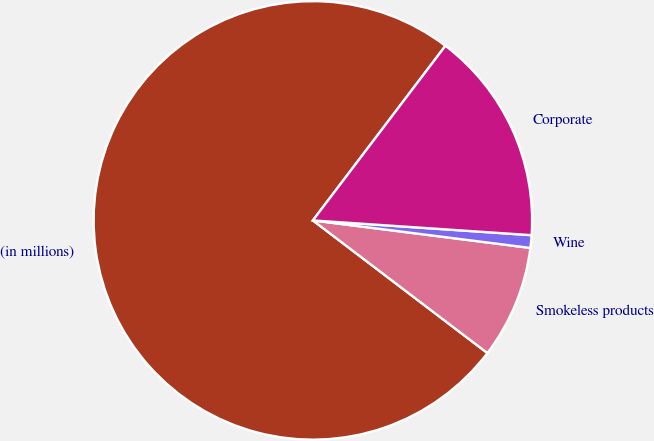Convert chart to OTSL. <chart><loc_0><loc_0><loc_500><loc_500><pie_chart><fcel>(in millions)<fcel>Smokeless products<fcel>Wine<fcel>Corporate<nl><fcel>74.99%<fcel>8.34%<fcel>0.93%<fcel>15.74%<nl></chart> 